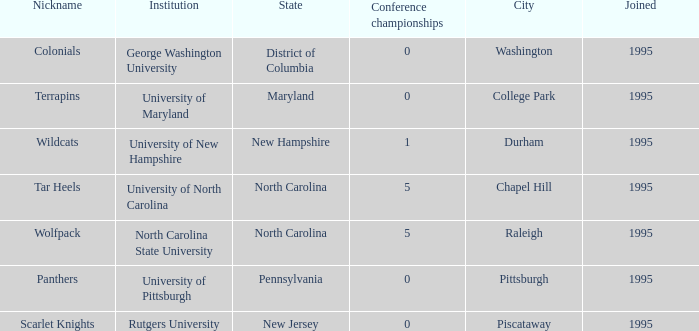What is the latest year joined with a Conference championships of 5, and an Institution of university of north carolina? 1995.0. 